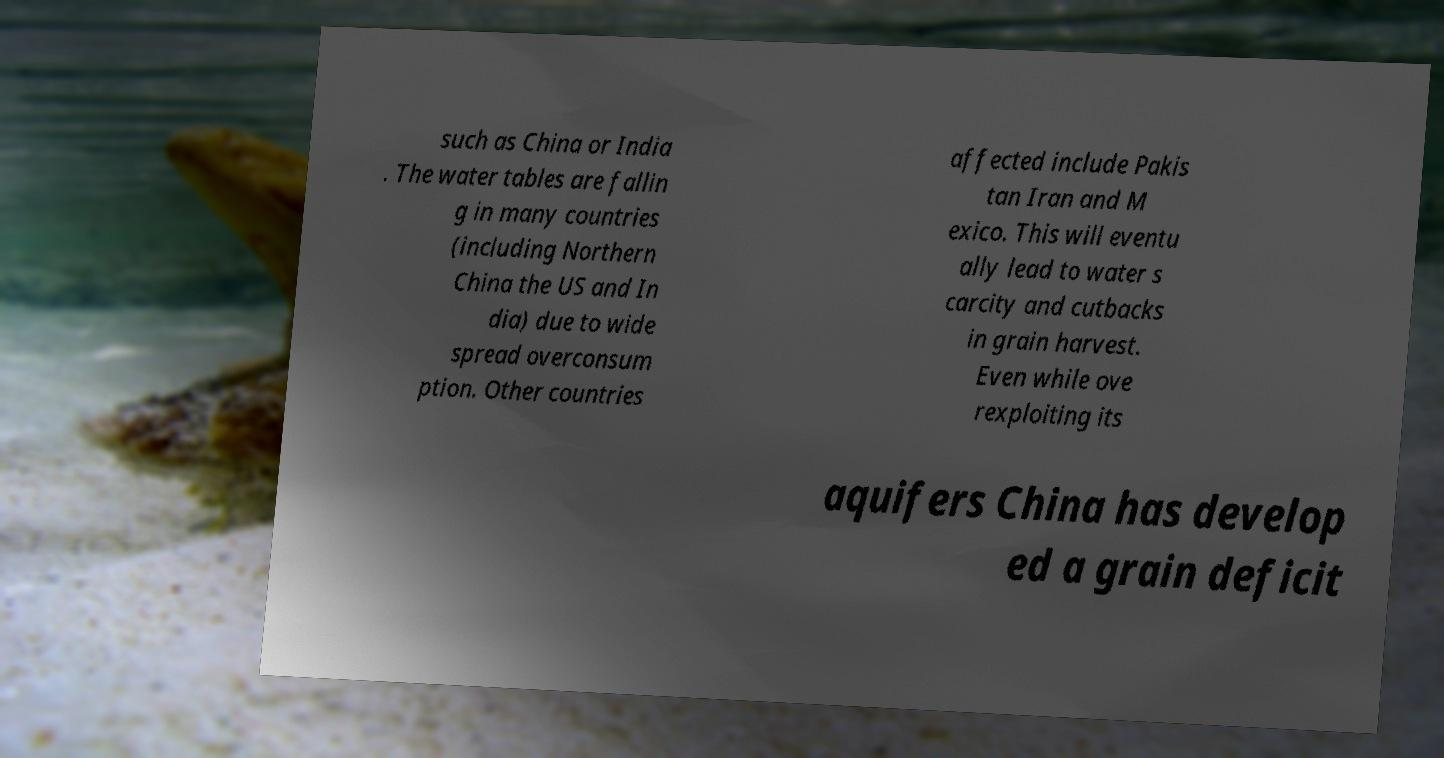For documentation purposes, I need the text within this image transcribed. Could you provide that? such as China or India . The water tables are fallin g in many countries (including Northern China the US and In dia) due to wide spread overconsum ption. Other countries affected include Pakis tan Iran and M exico. This will eventu ally lead to water s carcity and cutbacks in grain harvest. Even while ove rexploiting its aquifers China has develop ed a grain deficit 